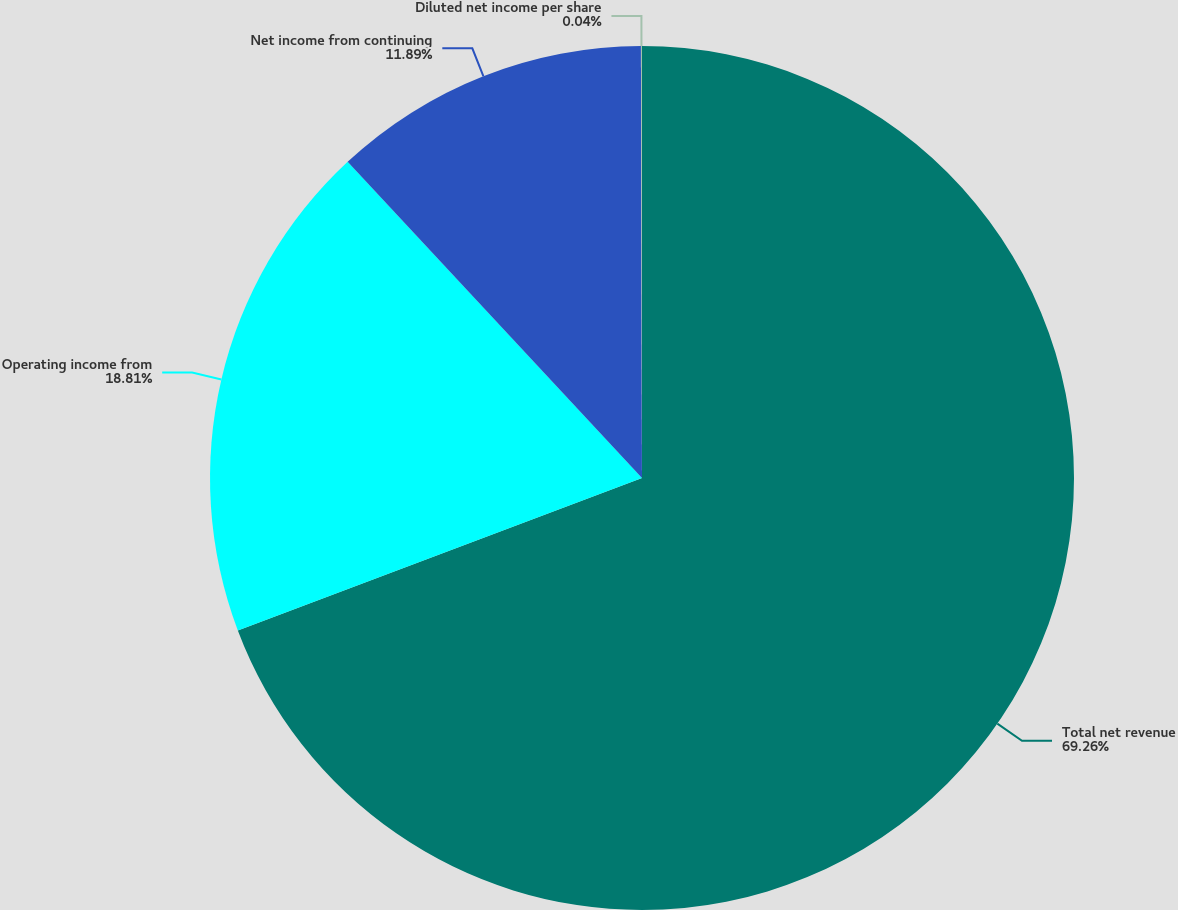Convert chart to OTSL. <chart><loc_0><loc_0><loc_500><loc_500><pie_chart><fcel>Total net revenue<fcel>Operating income from<fcel>Net income from continuing<fcel>Diluted net income per share<nl><fcel>69.25%<fcel>18.81%<fcel>11.89%<fcel>0.04%<nl></chart> 